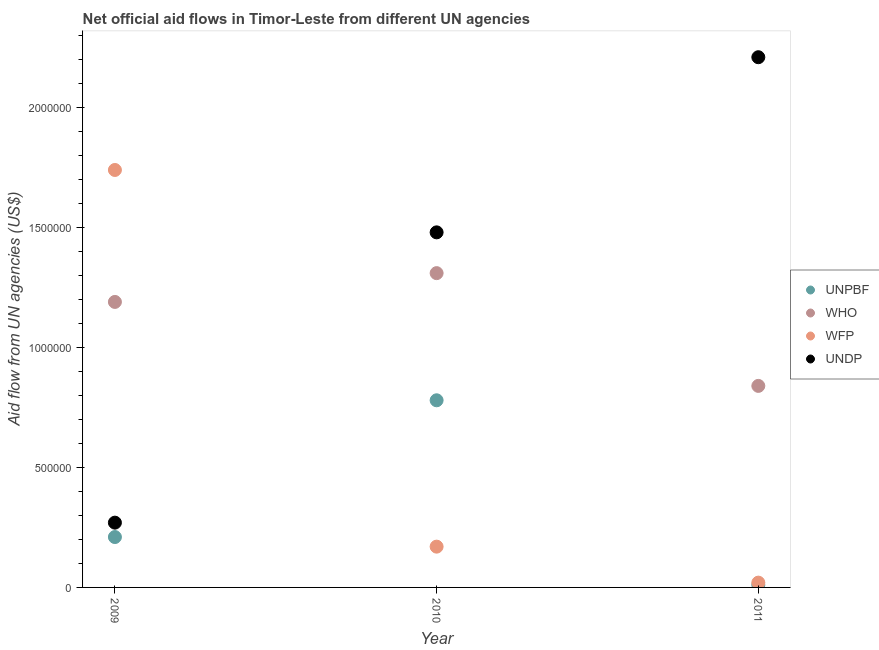How many different coloured dotlines are there?
Provide a succinct answer. 4. What is the amount of aid given by unpbf in 2010?
Provide a succinct answer. 7.80e+05. Across all years, what is the maximum amount of aid given by wfp?
Ensure brevity in your answer.  1.74e+06. Across all years, what is the minimum amount of aid given by undp?
Make the answer very short. 2.70e+05. In which year was the amount of aid given by undp maximum?
Provide a short and direct response. 2011. In which year was the amount of aid given by who minimum?
Your answer should be compact. 2011. What is the total amount of aid given by unpbf in the graph?
Provide a succinct answer. 1.00e+06. What is the difference between the amount of aid given by wfp in 2010 and that in 2011?
Ensure brevity in your answer.  1.50e+05. What is the difference between the amount of aid given by unpbf in 2011 and the amount of aid given by wfp in 2009?
Make the answer very short. -1.73e+06. What is the average amount of aid given by wfp per year?
Provide a short and direct response. 6.43e+05. In the year 2010, what is the difference between the amount of aid given by undp and amount of aid given by wfp?
Keep it short and to the point. 1.31e+06. In how many years, is the amount of aid given by who greater than 2100000 US$?
Your answer should be compact. 0. What is the ratio of the amount of aid given by undp in 2009 to that in 2010?
Offer a very short reply. 0.18. Is the difference between the amount of aid given by wfp in 2010 and 2011 greater than the difference between the amount of aid given by undp in 2010 and 2011?
Provide a succinct answer. Yes. What is the difference between the highest and the second highest amount of aid given by undp?
Ensure brevity in your answer.  7.30e+05. What is the difference between the highest and the lowest amount of aid given by undp?
Give a very brief answer. 1.94e+06. Is the sum of the amount of aid given by unpbf in 2009 and 2010 greater than the maximum amount of aid given by who across all years?
Your answer should be compact. No. Is it the case that in every year, the sum of the amount of aid given by unpbf and amount of aid given by wfp is greater than the sum of amount of aid given by who and amount of aid given by undp?
Provide a short and direct response. No. Does the amount of aid given by undp monotonically increase over the years?
Your answer should be very brief. Yes. Is the amount of aid given by undp strictly greater than the amount of aid given by unpbf over the years?
Provide a succinct answer. Yes. How many dotlines are there?
Ensure brevity in your answer.  4. How many years are there in the graph?
Provide a succinct answer. 3. What is the difference between two consecutive major ticks on the Y-axis?
Provide a short and direct response. 5.00e+05. Are the values on the major ticks of Y-axis written in scientific E-notation?
Offer a very short reply. No. Does the graph contain any zero values?
Your response must be concise. No. Does the graph contain grids?
Provide a short and direct response. No. Where does the legend appear in the graph?
Your answer should be very brief. Center right. What is the title of the graph?
Your answer should be compact. Net official aid flows in Timor-Leste from different UN agencies. What is the label or title of the Y-axis?
Keep it short and to the point. Aid flow from UN agencies (US$). What is the Aid flow from UN agencies (US$) of UNPBF in 2009?
Ensure brevity in your answer.  2.10e+05. What is the Aid flow from UN agencies (US$) of WHO in 2009?
Your answer should be very brief. 1.19e+06. What is the Aid flow from UN agencies (US$) in WFP in 2009?
Provide a short and direct response. 1.74e+06. What is the Aid flow from UN agencies (US$) in UNPBF in 2010?
Offer a very short reply. 7.80e+05. What is the Aid flow from UN agencies (US$) in WHO in 2010?
Make the answer very short. 1.31e+06. What is the Aid flow from UN agencies (US$) in WFP in 2010?
Offer a very short reply. 1.70e+05. What is the Aid flow from UN agencies (US$) in UNDP in 2010?
Provide a succinct answer. 1.48e+06. What is the Aid flow from UN agencies (US$) in UNPBF in 2011?
Offer a terse response. 10000. What is the Aid flow from UN agencies (US$) of WHO in 2011?
Offer a terse response. 8.40e+05. What is the Aid flow from UN agencies (US$) of WFP in 2011?
Provide a succinct answer. 2.00e+04. What is the Aid flow from UN agencies (US$) in UNDP in 2011?
Make the answer very short. 2.21e+06. Across all years, what is the maximum Aid flow from UN agencies (US$) in UNPBF?
Keep it short and to the point. 7.80e+05. Across all years, what is the maximum Aid flow from UN agencies (US$) of WHO?
Offer a terse response. 1.31e+06. Across all years, what is the maximum Aid flow from UN agencies (US$) of WFP?
Provide a succinct answer. 1.74e+06. Across all years, what is the maximum Aid flow from UN agencies (US$) of UNDP?
Ensure brevity in your answer.  2.21e+06. Across all years, what is the minimum Aid flow from UN agencies (US$) of UNPBF?
Offer a very short reply. 10000. Across all years, what is the minimum Aid flow from UN agencies (US$) in WHO?
Offer a terse response. 8.40e+05. What is the total Aid flow from UN agencies (US$) in UNPBF in the graph?
Provide a short and direct response. 1.00e+06. What is the total Aid flow from UN agencies (US$) in WHO in the graph?
Your answer should be compact. 3.34e+06. What is the total Aid flow from UN agencies (US$) of WFP in the graph?
Ensure brevity in your answer.  1.93e+06. What is the total Aid flow from UN agencies (US$) of UNDP in the graph?
Give a very brief answer. 3.96e+06. What is the difference between the Aid flow from UN agencies (US$) in UNPBF in 2009 and that in 2010?
Your answer should be compact. -5.70e+05. What is the difference between the Aid flow from UN agencies (US$) in WHO in 2009 and that in 2010?
Offer a terse response. -1.20e+05. What is the difference between the Aid flow from UN agencies (US$) of WFP in 2009 and that in 2010?
Keep it short and to the point. 1.57e+06. What is the difference between the Aid flow from UN agencies (US$) in UNDP in 2009 and that in 2010?
Ensure brevity in your answer.  -1.21e+06. What is the difference between the Aid flow from UN agencies (US$) in UNPBF in 2009 and that in 2011?
Make the answer very short. 2.00e+05. What is the difference between the Aid flow from UN agencies (US$) in WFP in 2009 and that in 2011?
Your response must be concise. 1.72e+06. What is the difference between the Aid flow from UN agencies (US$) of UNDP in 2009 and that in 2011?
Provide a short and direct response. -1.94e+06. What is the difference between the Aid flow from UN agencies (US$) in UNPBF in 2010 and that in 2011?
Offer a terse response. 7.70e+05. What is the difference between the Aid flow from UN agencies (US$) of WHO in 2010 and that in 2011?
Make the answer very short. 4.70e+05. What is the difference between the Aid flow from UN agencies (US$) in UNDP in 2010 and that in 2011?
Make the answer very short. -7.30e+05. What is the difference between the Aid flow from UN agencies (US$) in UNPBF in 2009 and the Aid flow from UN agencies (US$) in WHO in 2010?
Offer a terse response. -1.10e+06. What is the difference between the Aid flow from UN agencies (US$) of UNPBF in 2009 and the Aid flow from UN agencies (US$) of WFP in 2010?
Provide a succinct answer. 4.00e+04. What is the difference between the Aid flow from UN agencies (US$) in UNPBF in 2009 and the Aid flow from UN agencies (US$) in UNDP in 2010?
Provide a succinct answer. -1.27e+06. What is the difference between the Aid flow from UN agencies (US$) of WHO in 2009 and the Aid flow from UN agencies (US$) of WFP in 2010?
Provide a succinct answer. 1.02e+06. What is the difference between the Aid flow from UN agencies (US$) of WHO in 2009 and the Aid flow from UN agencies (US$) of UNDP in 2010?
Offer a terse response. -2.90e+05. What is the difference between the Aid flow from UN agencies (US$) of UNPBF in 2009 and the Aid flow from UN agencies (US$) of WHO in 2011?
Offer a terse response. -6.30e+05. What is the difference between the Aid flow from UN agencies (US$) in UNPBF in 2009 and the Aid flow from UN agencies (US$) in UNDP in 2011?
Make the answer very short. -2.00e+06. What is the difference between the Aid flow from UN agencies (US$) in WHO in 2009 and the Aid flow from UN agencies (US$) in WFP in 2011?
Your answer should be compact. 1.17e+06. What is the difference between the Aid flow from UN agencies (US$) of WHO in 2009 and the Aid flow from UN agencies (US$) of UNDP in 2011?
Keep it short and to the point. -1.02e+06. What is the difference between the Aid flow from UN agencies (US$) of WFP in 2009 and the Aid flow from UN agencies (US$) of UNDP in 2011?
Ensure brevity in your answer.  -4.70e+05. What is the difference between the Aid flow from UN agencies (US$) of UNPBF in 2010 and the Aid flow from UN agencies (US$) of WHO in 2011?
Your response must be concise. -6.00e+04. What is the difference between the Aid flow from UN agencies (US$) of UNPBF in 2010 and the Aid flow from UN agencies (US$) of WFP in 2011?
Provide a short and direct response. 7.60e+05. What is the difference between the Aid flow from UN agencies (US$) of UNPBF in 2010 and the Aid flow from UN agencies (US$) of UNDP in 2011?
Provide a short and direct response. -1.43e+06. What is the difference between the Aid flow from UN agencies (US$) in WHO in 2010 and the Aid flow from UN agencies (US$) in WFP in 2011?
Offer a terse response. 1.29e+06. What is the difference between the Aid flow from UN agencies (US$) of WHO in 2010 and the Aid flow from UN agencies (US$) of UNDP in 2011?
Offer a very short reply. -9.00e+05. What is the difference between the Aid flow from UN agencies (US$) of WFP in 2010 and the Aid flow from UN agencies (US$) of UNDP in 2011?
Provide a short and direct response. -2.04e+06. What is the average Aid flow from UN agencies (US$) of UNPBF per year?
Make the answer very short. 3.33e+05. What is the average Aid flow from UN agencies (US$) of WHO per year?
Ensure brevity in your answer.  1.11e+06. What is the average Aid flow from UN agencies (US$) in WFP per year?
Ensure brevity in your answer.  6.43e+05. What is the average Aid flow from UN agencies (US$) in UNDP per year?
Give a very brief answer. 1.32e+06. In the year 2009, what is the difference between the Aid flow from UN agencies (US$) in UNPBF and Aid flow from UN agencies (US$) in WHO?
Provide a short and direct response. -9.80e+05. In the year 2009, what is the difference between the Aid flow from UN agencies (US$) in UNPBF and Aid flow from UN agencies (US$) in WFP?
Offer a very short reply. -1.53e+06. In the year 2009, what is the difference between the Aid flow from UN agencies (US$) in WHO and Aid flow from UN agencies (US$) in WFP?
Make the answer very short. -5.50e+05. In the year 2009, what is the difference between the Aid flow from UN agencies (US$) of WHO and Aid flow from UN agencies (US$) of UNDP?
Offer a very short reply. 9.20e+05. In the year 2009, what is the difference between the Aid flow from UN agencies (US$) in WFP and Aid flow from UN agencies (US$) in UNDP?
Offer a terse response. 1.47e+06. In the year 2010, what is the difference between the Aid flow from UN agencies (US$) of UNPBF and Aid flow from UN agencies (US$) of WHO?
Offer a very short reply. -5.30e+05. In the year 2010, what is the difference between the Aid flow from UN agencies (US$) of UNPBF and Aid flow from UN agencies (US$) of WFP?
Keep it short and to the point. 6.10e+05. In the year 2010, what is the difference between the Aid flow from UN agencies (US$) in UNPBF and Aid flow from UN agencies (US$) in UNDP?
Your answer should be compact. -7.00e+05. In the year 2010, what is the difference between the Aid flow from UN agencies (US$) in WHO and Aid flow from UN agencies (US$) in WFP?
Ensure brevity in your answer.  1.14e+06. In the year 2010, what is the difference between the Aid flow from UN agencies (US$) of WHO and Aid flow from UN agencies (US$) of UNDP?
Provide a succinct answer. -1.70e+05. In the year 2010, what is the difference between the Aid flow from UN agencies (US$) of WFP and Aid flow from UN agencies (US$) of UNDP?
Offer a terse response. -1.31e+06. In the year 2011, what is the difference between the Aid flow from UN agencies (US$) in UNPBF and Aid flow from UN agencies (US$) in WHO?
Keep it short and to the point. -8.30e+05. In the year 2011, what is the difference between the Aid flow from UN agencies (US$) in UNPBF and Aid flow from UN agencies (US$) in WFP?
Your response must be concise. -10000. In the year 2011, what is the difference between the Aid flow from UN agencies (US$) in UNPBF and Aid flow from UN agencies (US$) in UNDP?
Provide a short and direct response. -2.20e+06. In the year 2011, what is the difference between the Aid flow from UN agencies (US$) of WHO and Aid flow from UN agencies (US$) of WFP?
Your answer should be compact. 8.20e+05. In the year 2011, what is the difference between the Aid flow from UN agencies (US$) of WHO and Aid flow from UN agencies (US$) of UNDP?
Provide a short and direct response. -1.37e+06. In the year 2011, what is the difference between the Aid flow from UN agencies (US$) in WFP and Aid flow from UN agencies (US$) in UNDP?
Ensure brevity in your answer.  -2.19e+06. What is the ratio of the Aid flow from UN agencies (US$) in UNPBF in 2009 to that in 2010?
Your answer should be compact. 0.27. What is the ratio of the Aid flow from UN agencies (US$) in WHO in 2009 to that in 2010?
Ensure brevity in your answer.  0.91. What is the ratio of the Aid flow from UN agencies (US$) of WFP in 2009 to that in 2010?
Your answer should be compact. 10.24. What is the ratio of the Aid flow from UN agencies (US$) of UNDP in 2009 to that in 2010?
Provide a short and direct response. 0.18. What is the ratio of the Aid flow from UN agencies (US$) in WHO in 2009 to that in 2011?
Offer a terse response. 1.42. What is the ratio of the Aid flow from UN agencies (US$) of WFP in 2009 to that in 2011?
Give a very brief answer. 87. What is the ratio of the Aid flow from UN agencies (US$) in UNDP in 2009 to that in 2011?
Your response must be concise. 0.12. What is the ratio of the Aid flow from UN agencies (US$) in UNPBF in 2010 to that in 2011?
Offer a terse response. 78. What is the ratio of the Aid flow from UN agencies (US$) of WHO in 2010 to that in 2011?
Ensure brevity in your answer.  1.56. What is the ratio of the Aid flow from UN agencies (US$) of WFP in 2010 to that in 2011?
Your answer should be compact. 8.5. What is the ratio of the Aid flow from UN agencies (US$) of UNDP in 2010 to that in 2011?
Give a very brief answer. 0.67. What is the difference between the highest and the second highest Aid flow from UN agencies (US$) in UNPBF?
Keep it short and to the point. 5.70e+05. What is the difference between the highest and the second highest Aid flow from UN agencies (US$) in WHO?
Offer a very short reply. 1.20e+05. What is the difference between the highest and the second highest Aid flow from UN agencies (US$) of WFP?
Make the answer very short. 1.57e+06. What is the difference between the highest and the second highest Aid flow from UN agencies (US$) in UNDP?
Offer a terse response. 7.30e+05. What is the difference between the highest and the lowest Aid flow from UN agencies (US$) in UNPBF?
Your response must be concise. 7.70e+05. What is the difference between the highest and the lowest Aid flow from UN agencies (US$) in WFP?
Offer a terse response. 1.72e+06. What is the difference between the highest and the lowest Aid flow from UN agencies (US$) of UNDP?
Give a very brief answer. 1.94e+06. 